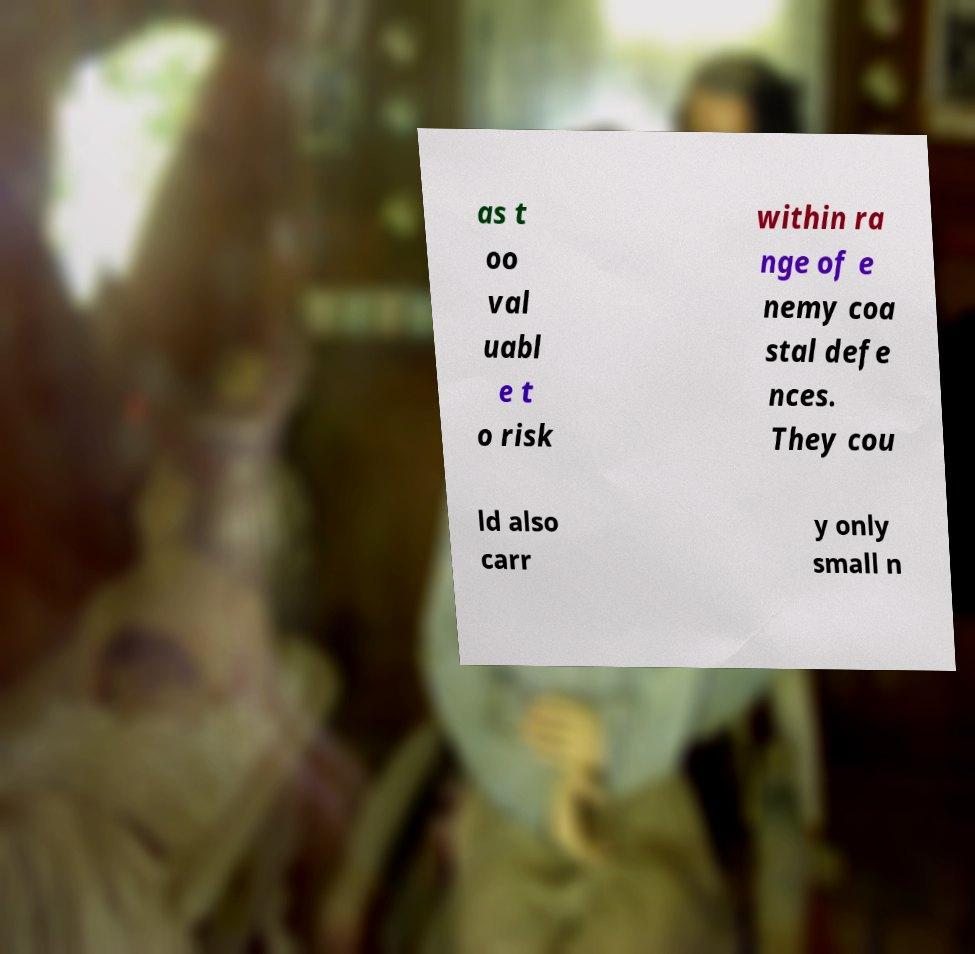I need the written content from this picture converted into text. Can you do that? as t oo val uabl e t o risk within ra nge of e nemy coa stal defe nces. They cou ld also carr y only small n 